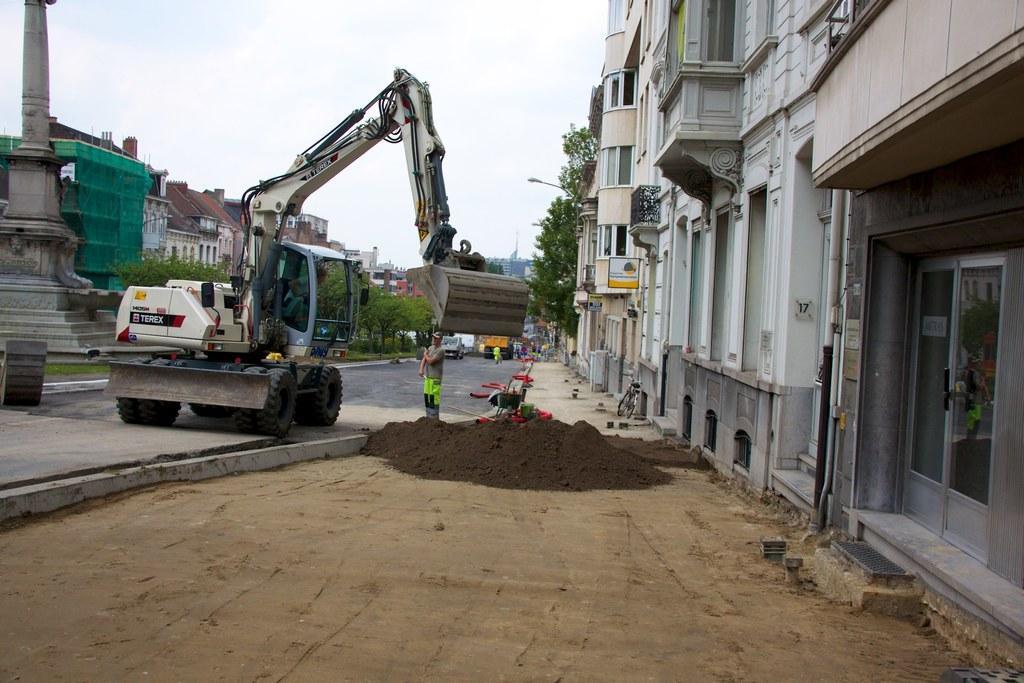Can you describe this image briefly? In this image I can see a road in the centre and on it I can see number of vehicles, few red colour things and few people. On the both sides of the image I can see number of buildings, number of trees and on the right side of the image I can see a bicycle. I can also see black soil on the ground. 